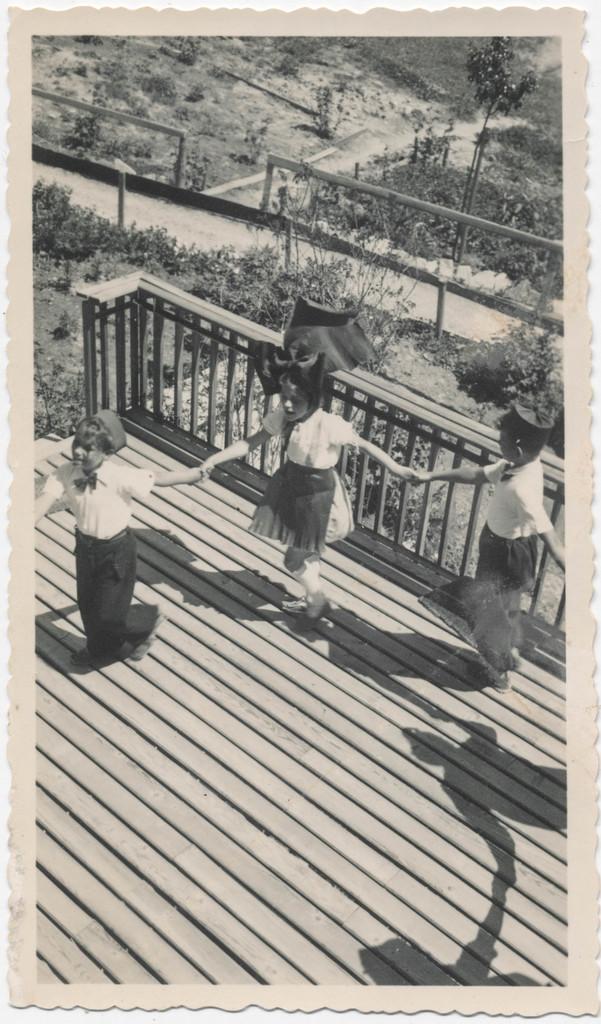How would you summarize this image in a sentence or two? In this image, we can see a poster which is black and white in color and there are three members who are playing, at the back of them there is a fencing and behind the fencing there are some plants. 